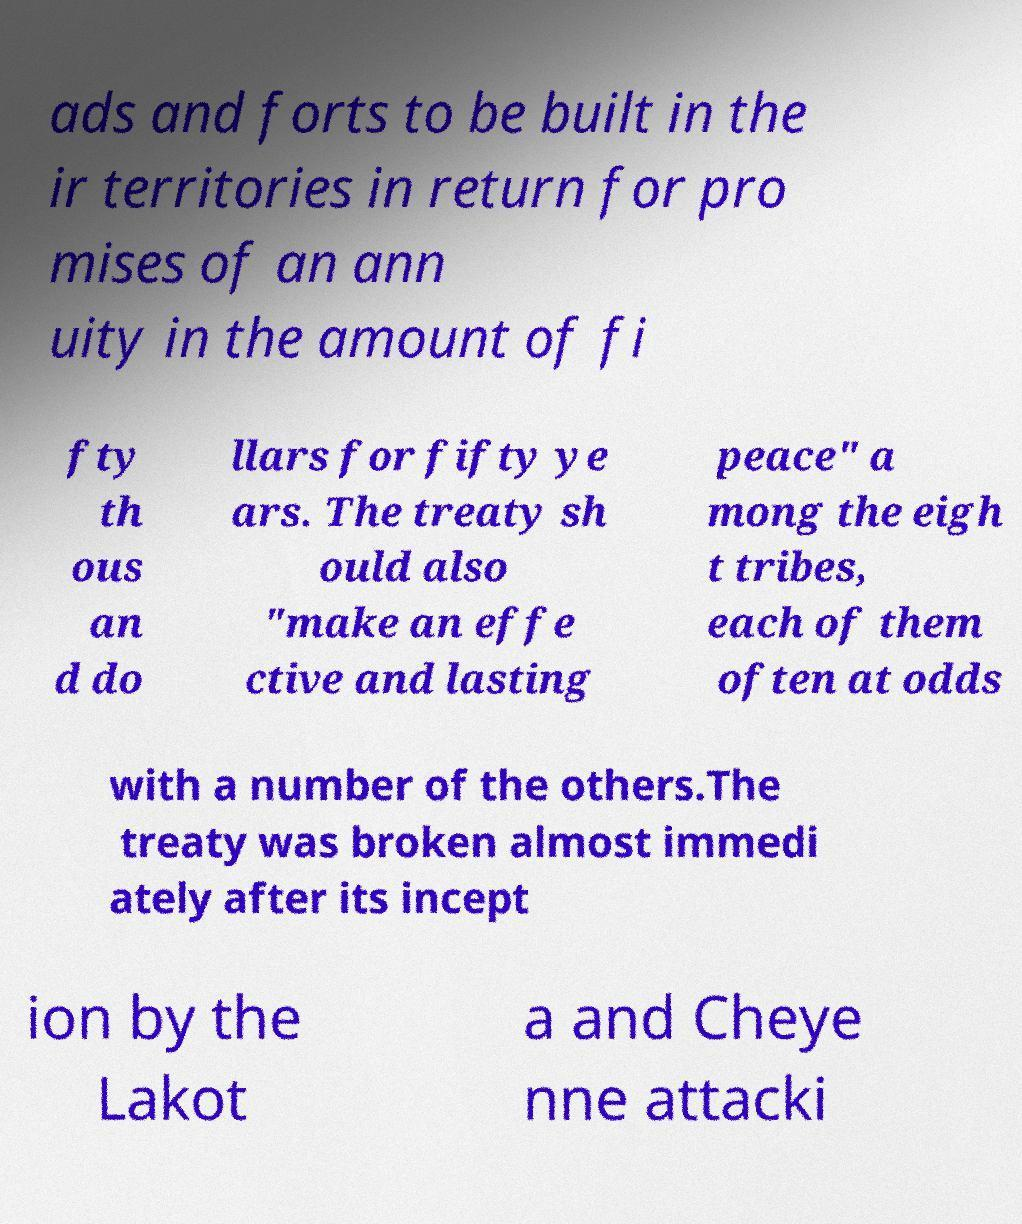There's text embedded in this image that I need extracted. Can you transcribe it verbatim? ads and forts to be built in the ir territories in return for pro mises of an ann uity in the amount of fi fty th ous an d do llars for fifty ye ars. The treaty sh ould also "make an effe ctive and lasting peace" a mong the eigh t tribes, each of them often at odds with a number of the others.The treaty was broken almost immedi ately after its incept ion by the Lakot a and Cheye nne attacki 